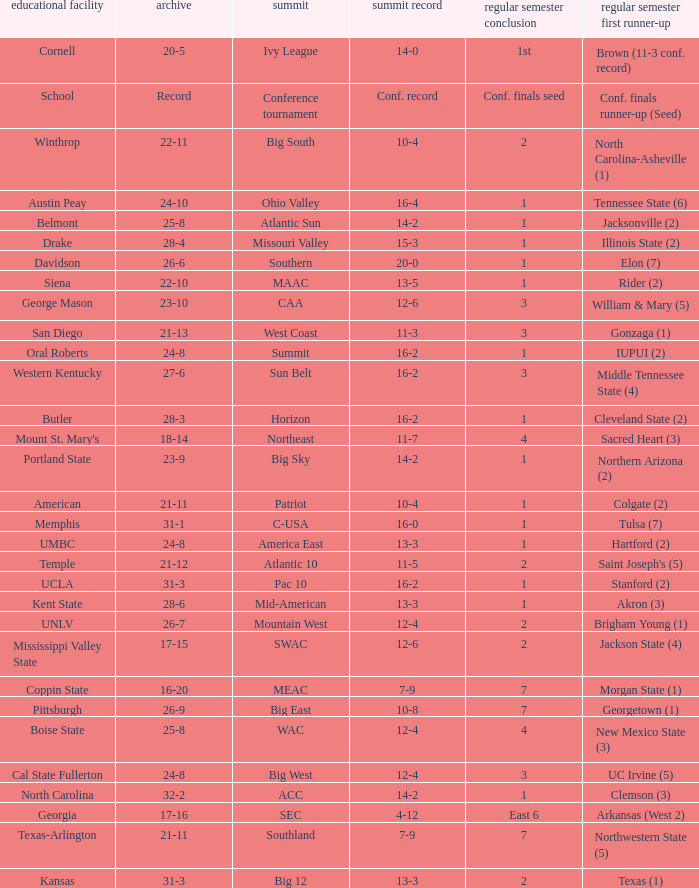For teams in the Sun Belt conference, what is the conference record? 16-2. 